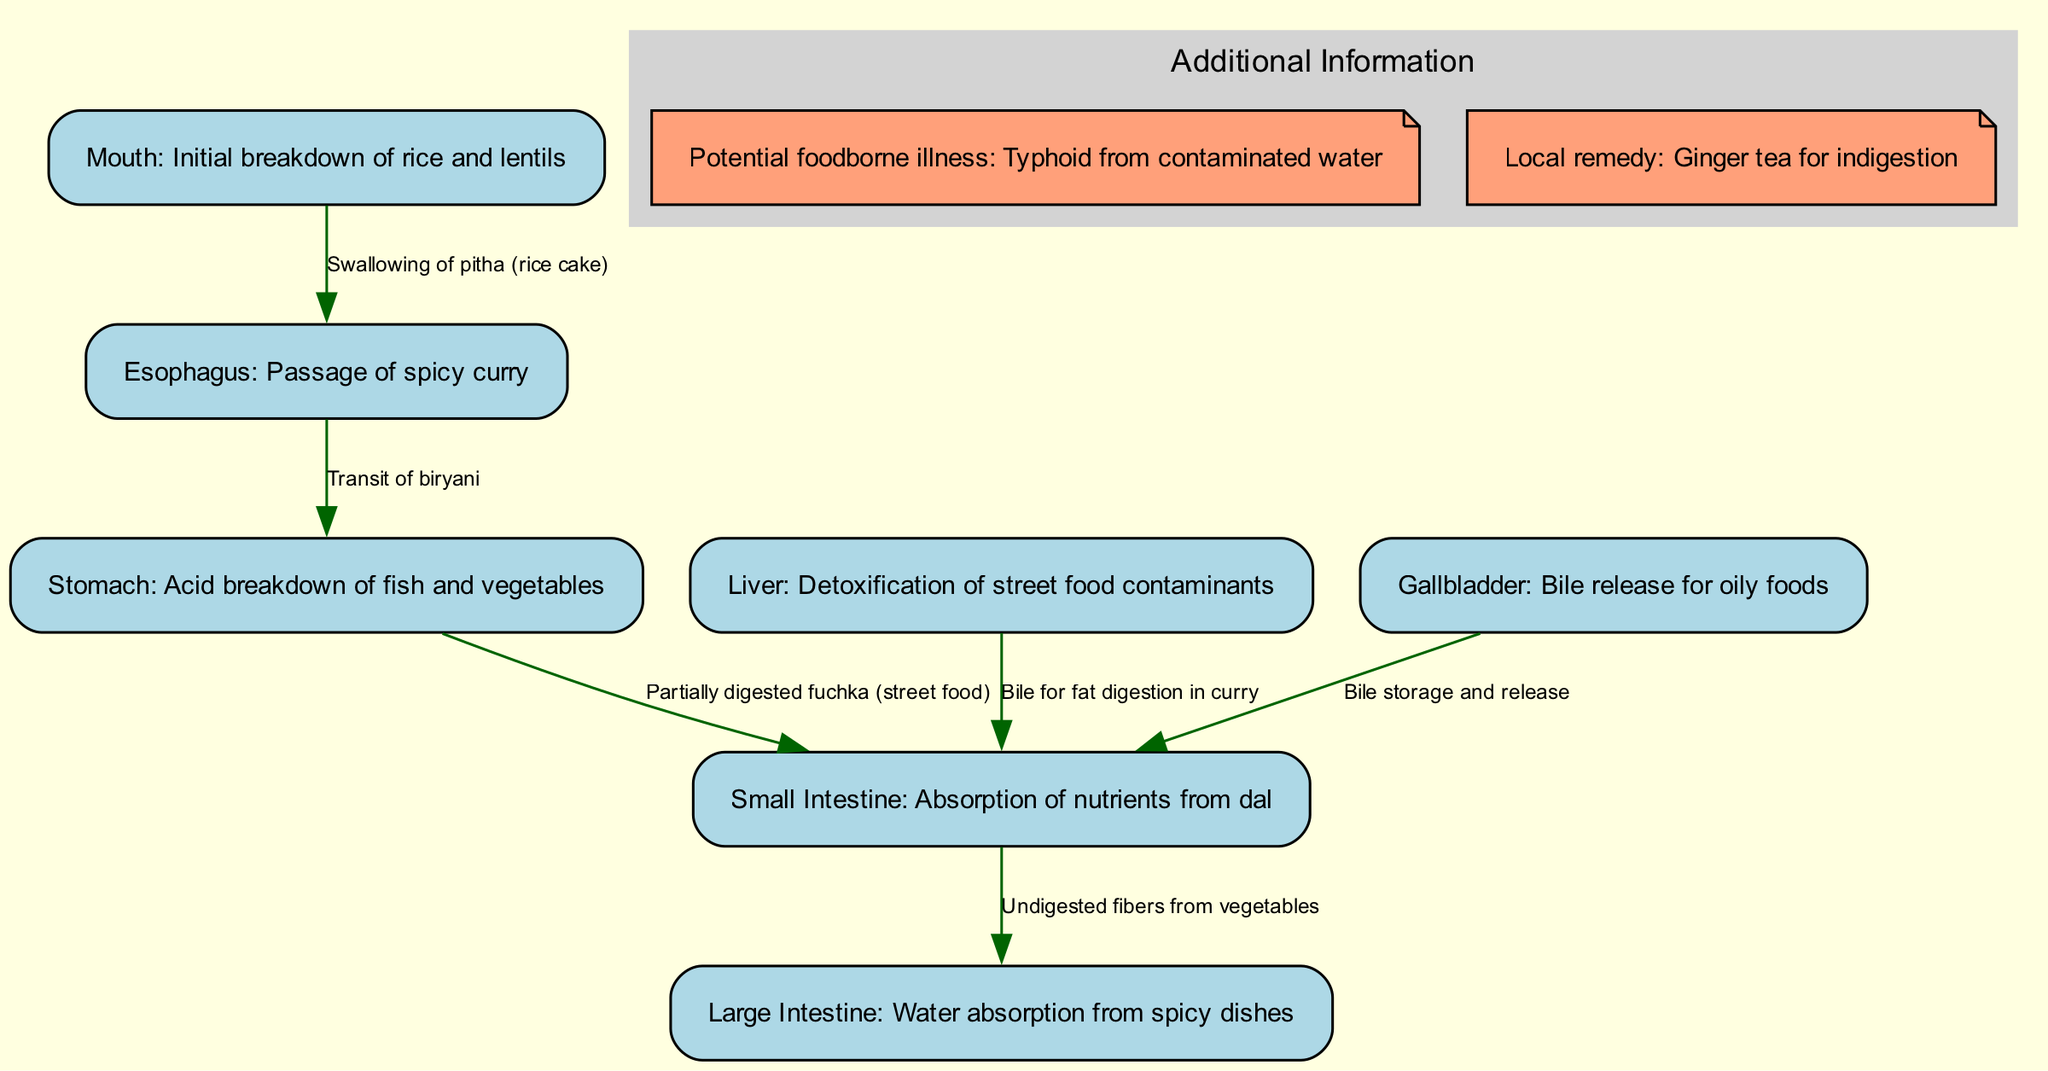What is the first step in the digestive system according to the diagram? The diagram indicates that the first step is the "Initial breakdown of rice and lentils" occurring in the mouth. The mouth is labeled as the starting point of digestion.
Answer: Mouth How many nodes are present in the diagram? The diagram includes a total of 7 nodes: mouth, esophagus, stomach, small intestine, large intestine, liver, and gallbladder. Counting these gives us 7 distinct parts of the digestive system.
Answer: 7 What substance is absorbed in the small intestine? The small intestine is described as the location for "Absorption of nutrients from dal." This indicates that dal provides important nutrients absorbed here.
Answer: Nutrients from dal What does the liver detoxify according to the diagram? The liver is labeled to perform the function of "Detoxification of street food contaminants" indicating it helps clean harmful substances from food consumed.
Answer: Street food contaminants Which food does the stomach break down? The stomach is responsible for the "Acid breakdown of fish and vegetables." This indicates that these foods are processed in the stomach for digestion.
Answer: Fish and vegetables What is the function of bile as depicted in the diagram? There are two references to bile: it is released by both the liver and gallbladder, specifically mentioned as "Bile for fat digestion in curry" and "Bile storage and release." This shows bile supports the digestion of fatty components in the diet.
Answer: Fat digestion in curry What potential foodborne illness is mentioned in the diagram? The diagram references "Typhoid from contaminated water" as a potential foodborne illness connected to local cuisine, indicating health risks associated with certain foods.
Answer: Typhoid Before the small intestine, which organ processes partially digested fuchka? The stomach is indicated as processing "Partially digested fuchka (street food)" before the food moves onward to the small intestine for further absorption.
Answer: Stomach What does the large intestine primarily do? The function of the large intestine is labeled as "Water absorption from spicy dishes," indicating its role in extracting fluids from the remaining food matter.
Answer: Water absorption from spicy dishes 